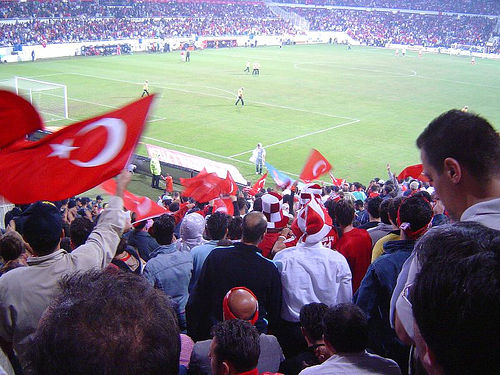<image>
Can you confirm if the red hat is in front of the bald head? Yes. The red hat is positioned in front of the bald head, appearing closer to the camera viewpoint. 